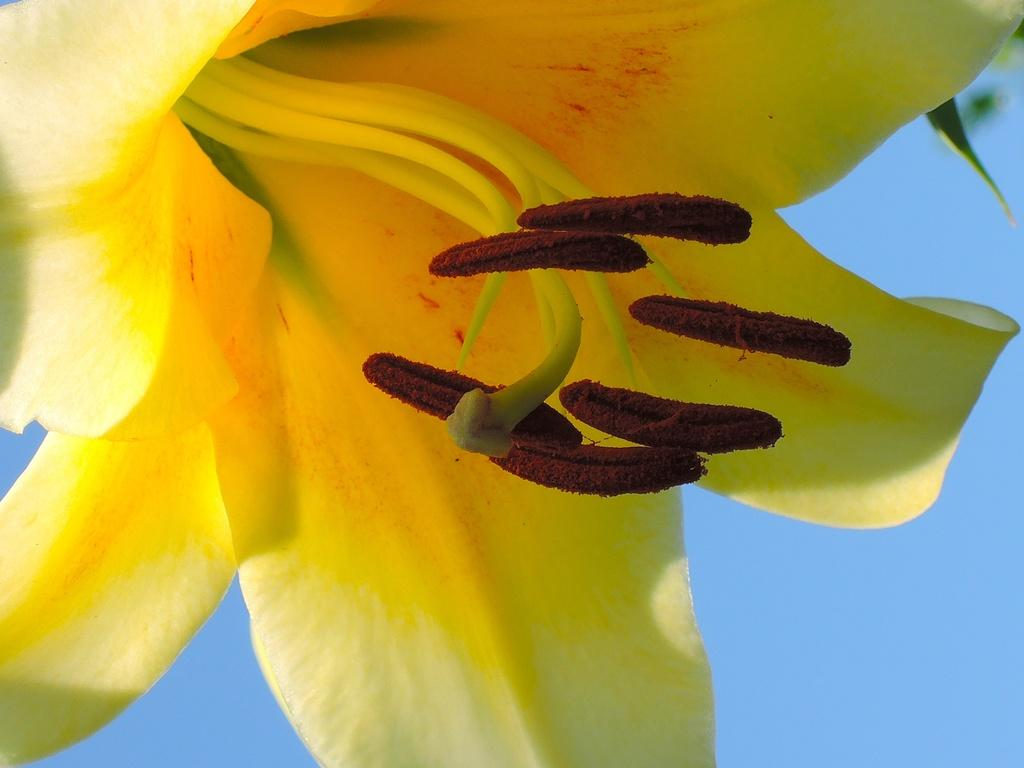What is the main subject of the image? There is a flower in the image. What can be seen in the background of the image? The sky is visible behind the flower in the image. What type of friction can be observed between the flower and the wall in the image? There is no wall present in the image, and therefore no friction between the flower and a wall can be observed. 